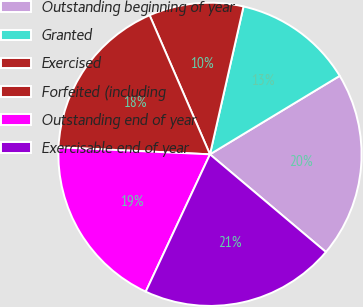Convert chart to OTSL. <chart><loc_0><loc_0><loc_500><loc_500><pie_chart><fcel>Outstanding beginning of year<fcel>Granted<fcel>Exercised<fcel>Forfeited (including<fcel>Outstanding end of year<fcel>Exercisable end of year<nl><fcel>19.8%<fcel>12.79%<fcel>10.07%<fcel>17.75%<fcel>18.77%<fcel>20.82%<nl></chart> 